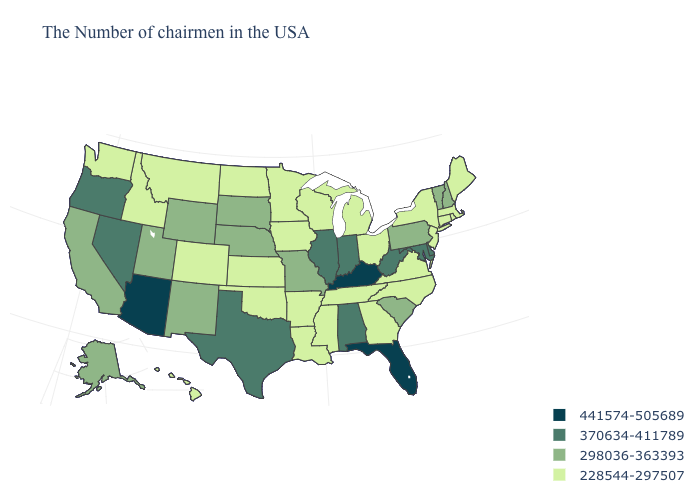Among the states that border Georgia , does Florida have the highest value?
Be succinct. Yes. What is the lowest value in the USA?
Concise answer only. 228544-297507. What is the lowest value in states that border Wisconsin?
Quick response, please. 228544-297507. Which states hav the highest value in the MidWest?
Keep it brief. Indiana, Illinois. Name the states that have a value in the range 370634-411789?
Write a very short answer. Delaware, Maryland, West Virginia, Indiana, Alabama, Illinois, Texas, Nevada, Oregon. Among the states that border Wisconsin , does Michigan have the highest value?
Quick response, please. No. Which states have the lowest value in the USA?
Write a very short answer. Maine, Massachusetts, Rhode Island, Connecticut, New York, New Jersey, Virginia, North Carolina, Ohio, Georgia, Michigan, Tennessee, Wisconsin, Mississippi, Louisiana, Arkansas, Minnesota, Iowa, Kansas, Oklahoma, North Dakota, Colorado, Montana, Idaho, Washington, Hawaii. Does the first symbol in the legend represent the smallest category?
Answer briefly. No. Among the states that border Nevada , does Idaho have the lowest value?
Quick response, please. Yes. What is the value of Oregon?
Give a very brief answer. 370634-411789. What is the lowest value in states that border Maryland?
Give a very brief answer. 228544-297507. Does the first symbol in the legend represent the smallest category?
Write a very short answer. No. Does Indiana have the lowest value in the USA?
Keep it brief. No. Does Connecticut have the highest value in the Northeast?
Give a very brief answer. No. What is the value of Delaware?
Answer briefly. 370634-411789. 